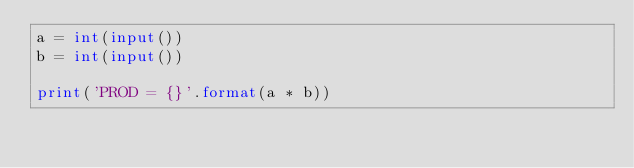<code> <loc_0><loc_0><loc_500><loc_500><_Python_>a = int(input())
b = int(input())

print('PROD = {}'.format(a * b))
</code> 